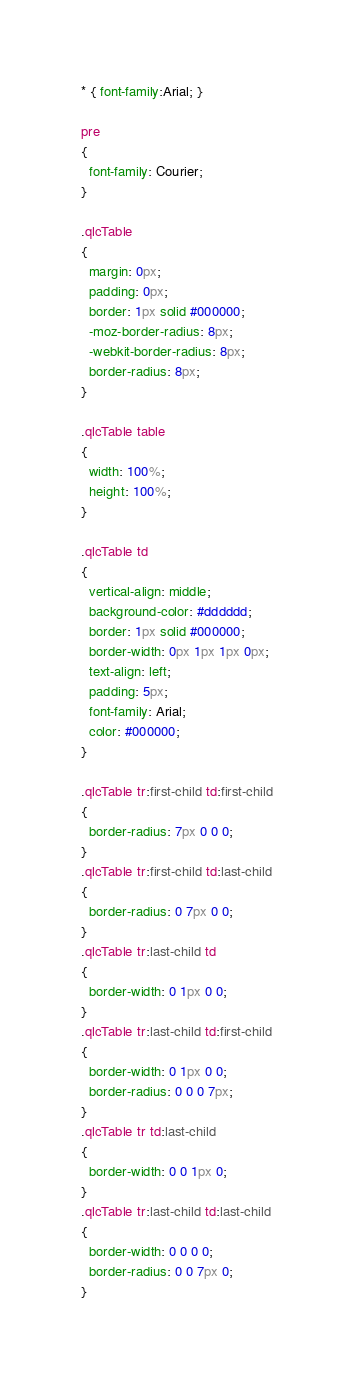<code> <loc_0><loc_0><loc_500><loc_500><_CSS_>* { font-family:Arial; }

pre
{
  font-family: Courier;
}

.qlcTable 
{
  margin: 0px;
  padding: 0px;
  border: 1px solid #000000;
  -moz-border-radius: 8px;
  -webkit-border-radius: 8px;
  border-radius: 8px;
}

.qlcTable table
{
  width: 100%;
  height: 100%;
}

.qlcTable td
{
  vertical-align: middle;
  background-color: #dddddd;
  border: 1px solid #000000;
  border-width: 0px 1px 1px 0px;
  text-align: left;
  padding: 5px;
  font-family: Arial;
  color: #000000;
}

.qlcTable tr:first-child td:first-child
{
  border-radius: 7px 0 0 0;
}
.qlcTable tr:first-child td:last-child
{
  border-radius: 0 7px 0 0;
}
.qlcTable tr:last-child td
{
  border-width: 0 1px 0 0;
}
.qlcTable tr:last-child td:first-child
{
  border-width: 0 1px 0 0;
  border-radius: 0 0 0 7px;
}
.qlcTable tr td:last-child
{
  border-width: 0 0 1px 0;
}
.qlcTable tr:last-child td:last-child
{
  border-width: 0 0 0 0;
  border-radius: 0 0 7px 0;
}
</code> 